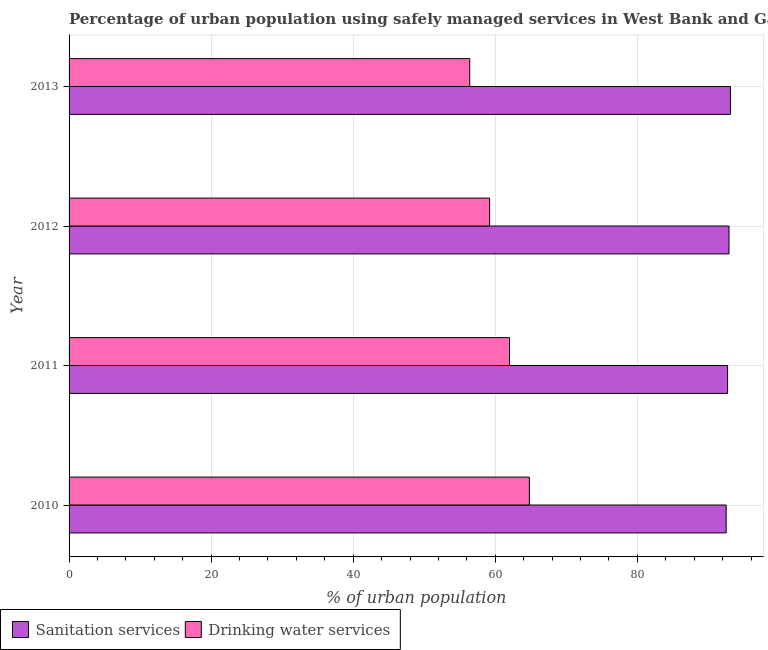How many different coloured bars are there?
Offer a very short reply. 2. Are the number of bars per tick equal to the number of legend labels?
Give a very brief answer. Yes. How many bars are there on the 1st tick from the top?
Your response must be concise. 2. How many bars are there on the 3rd tick from the bottom?
Keep it short and to the point. 2. What is the label of the 2nd group of bars from the top?
Keep it short and to the point. 2012. Across all years, what is the maximum percentage of urban population who used drinking water services?
Your answer should be compact. 64.8. Across all years, what is the minimum percentage of urban population who used sanitation services?
Keep it short and to the point. 92.5. In which year was the percentage of urban population who used drinking water services maximum?
Provide a short and direct response. 2010. In which year was the percentage of urban population who used sanitation services minimum?
Make the answer very short. 2010. What is the total percentage of urban population who used sanitation services in the graph?
Your answer should be compact. 371.2. What is the difference between the percentage of urban population who used drinking water services in 2011 and the percentage of urban population who used sanitation services in 2012?
Make the answer very short. -30.9. What is the average percentage of urban population who used drinking water services per year?
Give a very brief answer. 60.6. In the year 2010, what is the difference between the percentage of urban population who used drinking water services and percentage of urban population who used sanitation services?
Make the answer very short. -27.7. What is the ratio of the percentage of urban population who used drinking water services in 2011 to that in 2013?
Make the answer very short. 1.1. What is the difference between the highest and the lowest percentage of urban population who used sanitation services?
Provide a succinct answer. 0.6. In how many years, is the percentage of urban population who used drinking water services greater than the average percentage of urban population who used drinking water services taken over all years?
Ensure brevity in your answer.  2. Is the sum of the percentage of urban population who used sanitation services in 2010 and 2012 greater than the maximum percentage of urban population who used drinking water services across all years?
Keep it short and to the point. Yes. What does the 2nd bar from the top in 2013 represents?
Offer a very short reply. Sanitation services. What does the 1st bar from the bottom in 2011 represents?
Provide a succinct answer. Sanitation services. Are all the bars in the graph horizontal?
Offer a very short reply. Yes. Does the graph contain grids?
Offer a very short reply. Yes. Where does the legend appear in the graph?
Make the answer very short. Bottom left. What is the title of the graph?
Provide a short and direct response. Percentage of urban population using safely managed services in West Bank and Gaza. What is the label or title of the X-axis?
Give a very brief answer. % of urban population. What is the % of urban population of Sanitation services in 2010?
Offer a very short reply. 92.5. What is the % of urban population of Drinking water services in 2010?
Make the answer very short. 64.8. What is the % of urban population in Sanitation services in 2011?
Offer a very short reply. 92.7. What is the % of urban population of Drinking water services in 2011?
Make the answer very short. 62. What is the % of urban population in Sanitation services in 2012?
Provide a short and direct response. 92.9. What is the % of urban population in Drinking water services in 2012?
Offer a very short reply. 59.2. What is the % of urban population of Sanitation services in 2013?
Your response must be concise. 93.1. What is the % of urban population in Drinking water services in 2013?
Ensure brevity in your answer.  56.4. Across all years, what is the maximum % of urban population in Sanitation services?
Your answer should be very brief. 93.1. Across all years, what is the maximum % of urban population of Drinking water services?
Your answer should be compact. 64.8. Across all years, what is the minimum % of urban population in Sanitation services?
Your answer should be compact. 92.5. Across all years, what is the minimum % of urban population of Drinking water services?
Make the answer very short. 56.4. What is the total % of urban population in Sanitation services in the graph?
Provide a short and direct response. 371.2. What is the total % of urban population in Drinking water services in the graph?
Your answer should be very brief. 242.4. What is the difference between the % of urban population in Drinking water services in 2010 and that in 2011?
Your response must be concise. 2.8. What is the difference between the % of urban population of Drinking water services in 2010 and that in 2012?
Offer a terse response. 5.6. What is the difference between the % of urban population in Sanitation services in 2010 and that in 2013?
Offer a terse response. -0.6. What is the difference between the % of urban population of Sanitation services in 2011 and that in 2012?
Your answer should be compact. -0.2. What is the difference between the % of urban population in Sanitation services in 2011 and that in 2013?
Your response must be concise. -0.4. What is the difference between the % of urban population in Drinking water services in 2011 and that in 2013?
Provide a short and direct response. 5.6. What is the difference between the % of urban population of Sanitation services in 2012 and that in 2013?
Keep it short and to the point. -0.2. What is the difference between the % of urban population of Sanitation services in 2010 and the % of urban population of Drinking water services in 2011?
Offer a very short reply. 30.5. What is the difference between the % of urban population of Sanitation services in 2010 and the % of urban population of Drinking water services in 2012?
Your answer should be compact. 33.3. What is the difference between the % of urban population in Sanitation services in 2010 and the % of urban population in Drinking water services in 2013?
Your answer should be compact. 36.1. What is the difference between the % of urban population in Sanitation services in 2011 and the % of urban population in Drinking water services in 2012?
Make the answer very short. 33.5. What is the difference between the % of urban population of Sanitation services in 2011 and the % of urban population of Drinking water services in 2013?
Ensure brevity in your answer.  36.3. What is the difference between the % of urban population in Sanitation services in 2012 and the % of urban population in Drinking water services in 2013?
Your answer should be very brief. 36.5. What is the average % of urban population of Sanitation services per year?
Give a very brief answer. 92.8. What is the average % of urban population of Drinking water services per year?
Your answer should be very brief. 60.6. In the year 2010, what is the difference between the % of urban population in Sanitation services and % of urban population in Drinking water services?
Offer a very short reply. 27.7. In the year 2011, what is the difference between the % of urban population of Sanitation services and % of urban population of Drinking water services?
Offer a terse response. 30.7. In the year 2012, what is the difference between the % of urban population in Sanitation services and % of urban population in Drinking water services?
Ensure brevity in your answer.  33.7. In the year 2013, what is the difference between the % of urban population of Sanitation services and % of urban population of Drinking water services?
Your response must be concise. 36.7. What is the ratio of the % of urban population in Drinking water services in 2010 to that in 2011?
Give a very brief answer. 1.05. What is the ratio of the % of urban population in Sanitation services in 2010 to that in 2012?
Your response must be concise. 1. What is the ratio of the % of urban population in Drinking water services in 2010 to that in 2012?
Offer a terse response. 1.09. What is the ratio of the % of urban population in Sanitation services in 2010 to that in 2013?
Your answer should be very brief. 0.99. What is the ratio of the % of urban population of Drinking water services in 2010 to that in 2013?
Offer a very short reply. 1.15. What is the ratio of the % of urban population in Drinking water services in 2011 to that in 2012?
Provide a short and direct response. 1.05. What is the ratio of the % of urban population of Sanitation services in 2011 to that in 2013?
Ensure brevity in your answer.  1. What is the ratio of the % of urban population in Drinking water services in 2011 to that in 2013?
Your response must be concise. 1.1. What is the ratio of the % of urban population of Drinking water services in 2012 to that in 2013?
Your response must be concise. 1.05. What is the difference between the highest and the lowest % of urban population of Drinking water services?
Your answer should be compact. 8.4. 